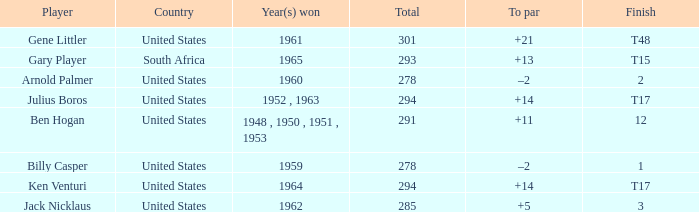What is Finish, when Country is "United States", and when Player is "Julius Boros"? T17. 